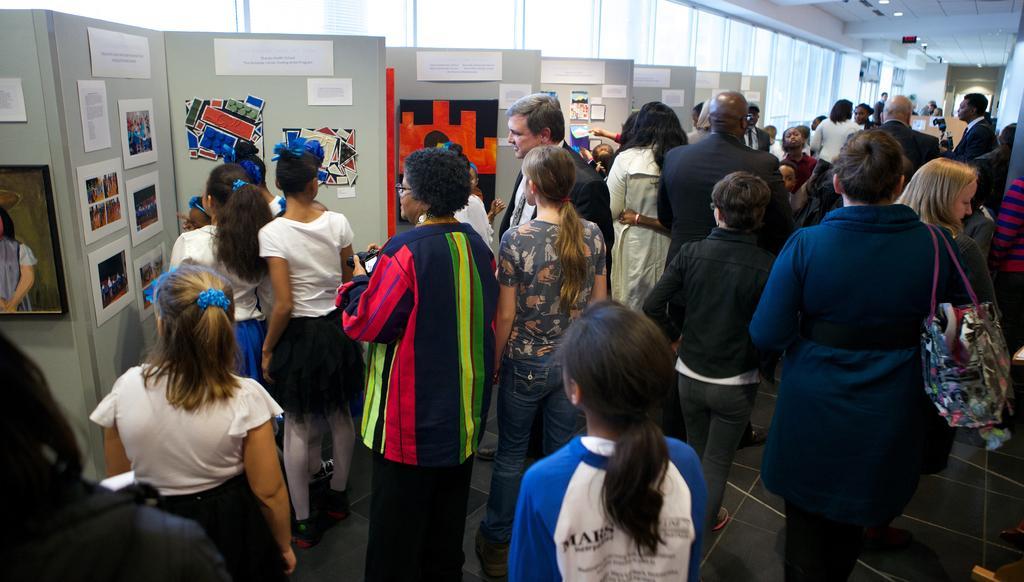Could you give a brief overview of what you see in this image? In this picture we can see some people standing, a person on the right side is carrying a bag, there are some papers and photos pasted on the left side, we can see a photo frame on the left side, in the background there are some curtains, we can see the ceiling at the right top of the picture. 